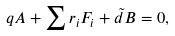<formula> <loc_0><loc_0><loc_500><loc_500>q A + \sum r _ { i } F _ { i } + { \tilde { d } } B = 0 ,</formula> 